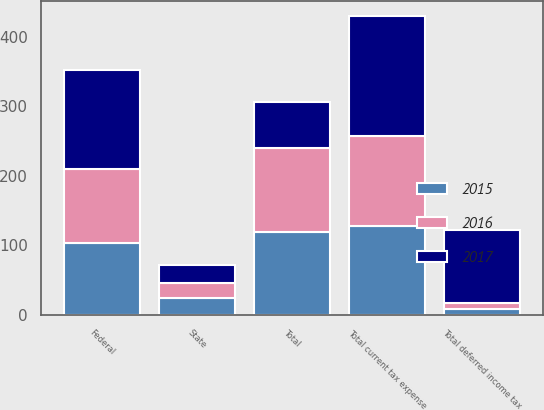Convert chart to OTSL. <chart><loc_0><loc_0><loc_500><loc_500><stacked_bar_chart><ecel><fcel>Federal<fcel>State<fcel>Total current tax expense<fcel>Total deferred income tax<fcel>Total<nl><fcel>2017<fcel>141<fcel>25.8<fcel>172.2<fcel>105.2<fcel>66.2<nl><fcel>2016<fcel>107.1<fcel>22.6<fcel>129.7<fcel>8.8<fcel>120.9<nl><fcel>2015<fcel>103.3<fcel>23.9<fcel>127.3<fcel>8.3<fcel>119<nl></chart> 